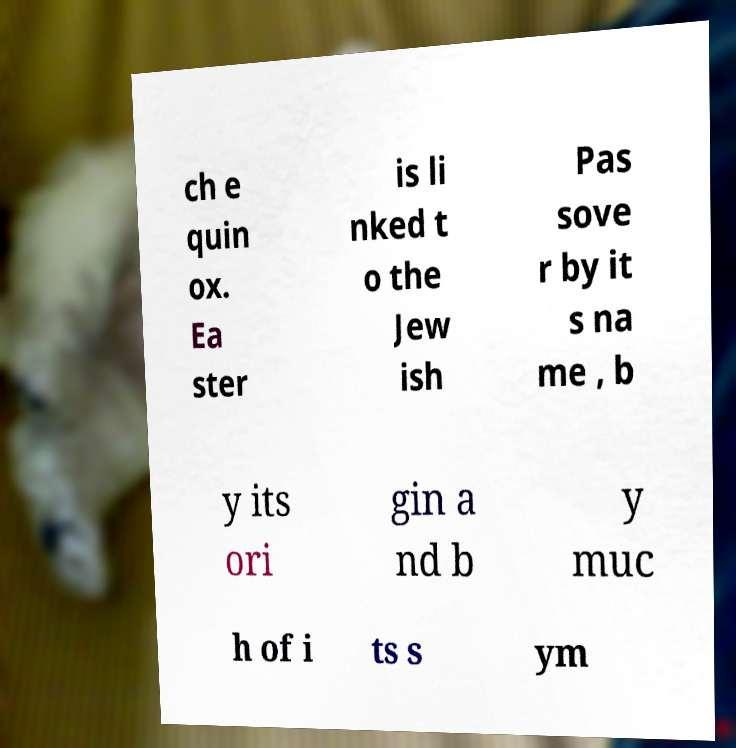I need the written content from this picture converted into text. Can you do that? ch e quin ox. Ea ster is li nked t o the Jew ish Pas sove r by it s na me , b y its ori gin a nd b y muc h of i ts s ym 